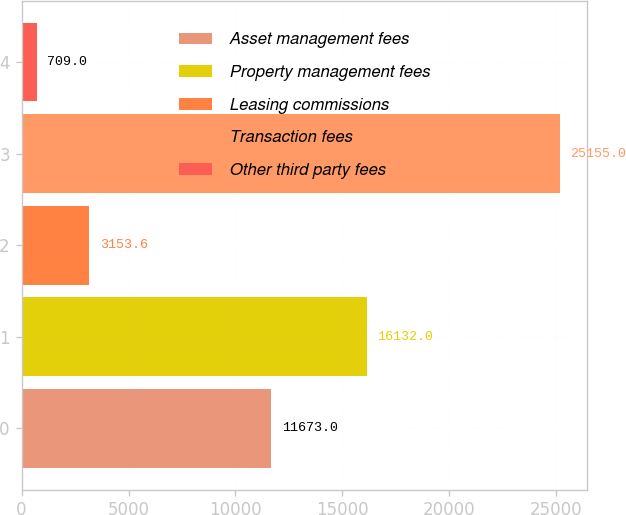<chart> <loc_0><loc_0><loc_500><loc_500><bar_chart><fcel>Asset management fees<fcel>Property management fees<fcel>Leasing commissions<fcel>Transaction fees<fcel>Other third party fees<nl><fcel>11673<fcel>16132<fcel>3153.6<fcel>25155<fcel>709<nl></chart> 